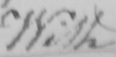What text is written in this handwritten line? With 